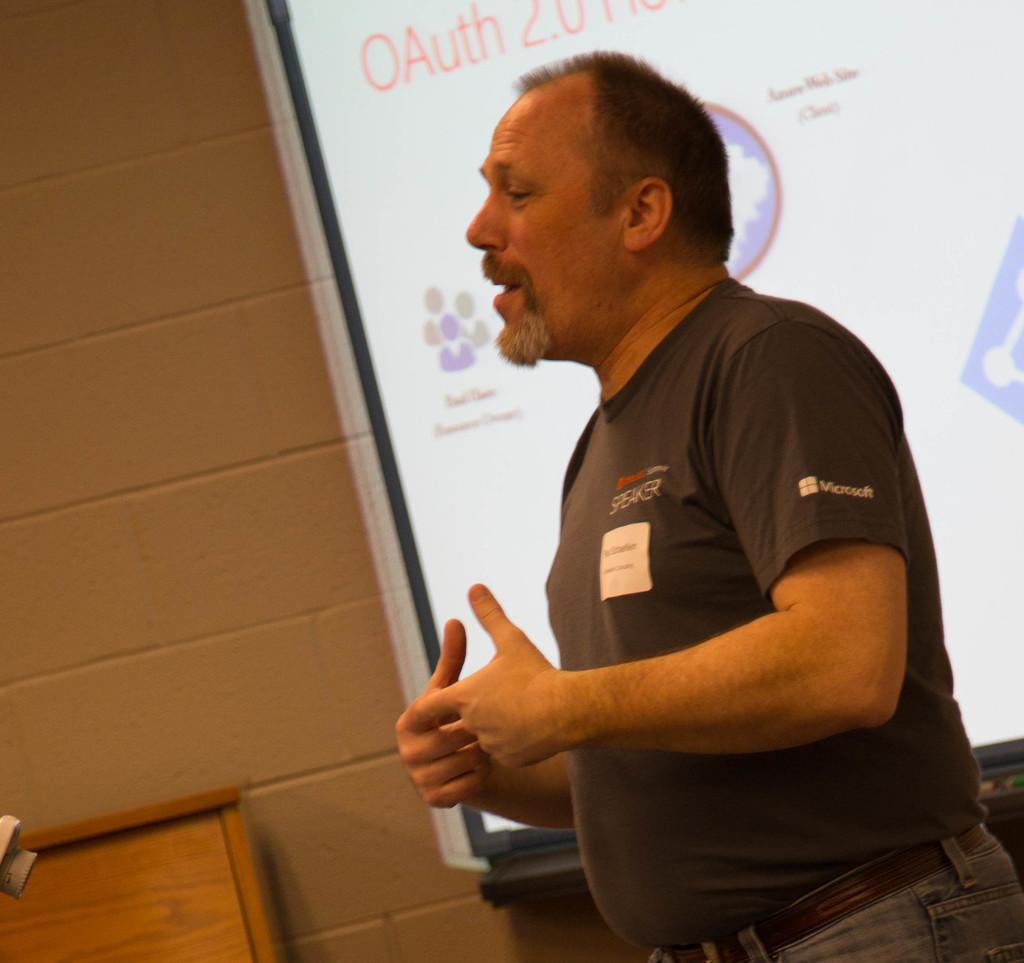What is the main subject of the image? There is a person in the image. What is the person wearing? The person is wearing a black t-shirt. What is the person doing in the image? The person is standing and speaking. What can be seen in the background of the image? There is a white color screen in the background, which is near a wall. What type of object is present in the background? There is a wooden object in the background. What type of pickle is the person holding in the image? There is no pickle present in the image. How is the person's sister involved in the scene? The facts provided do not mention a sister, so it cannot be determined how she might be involved. 